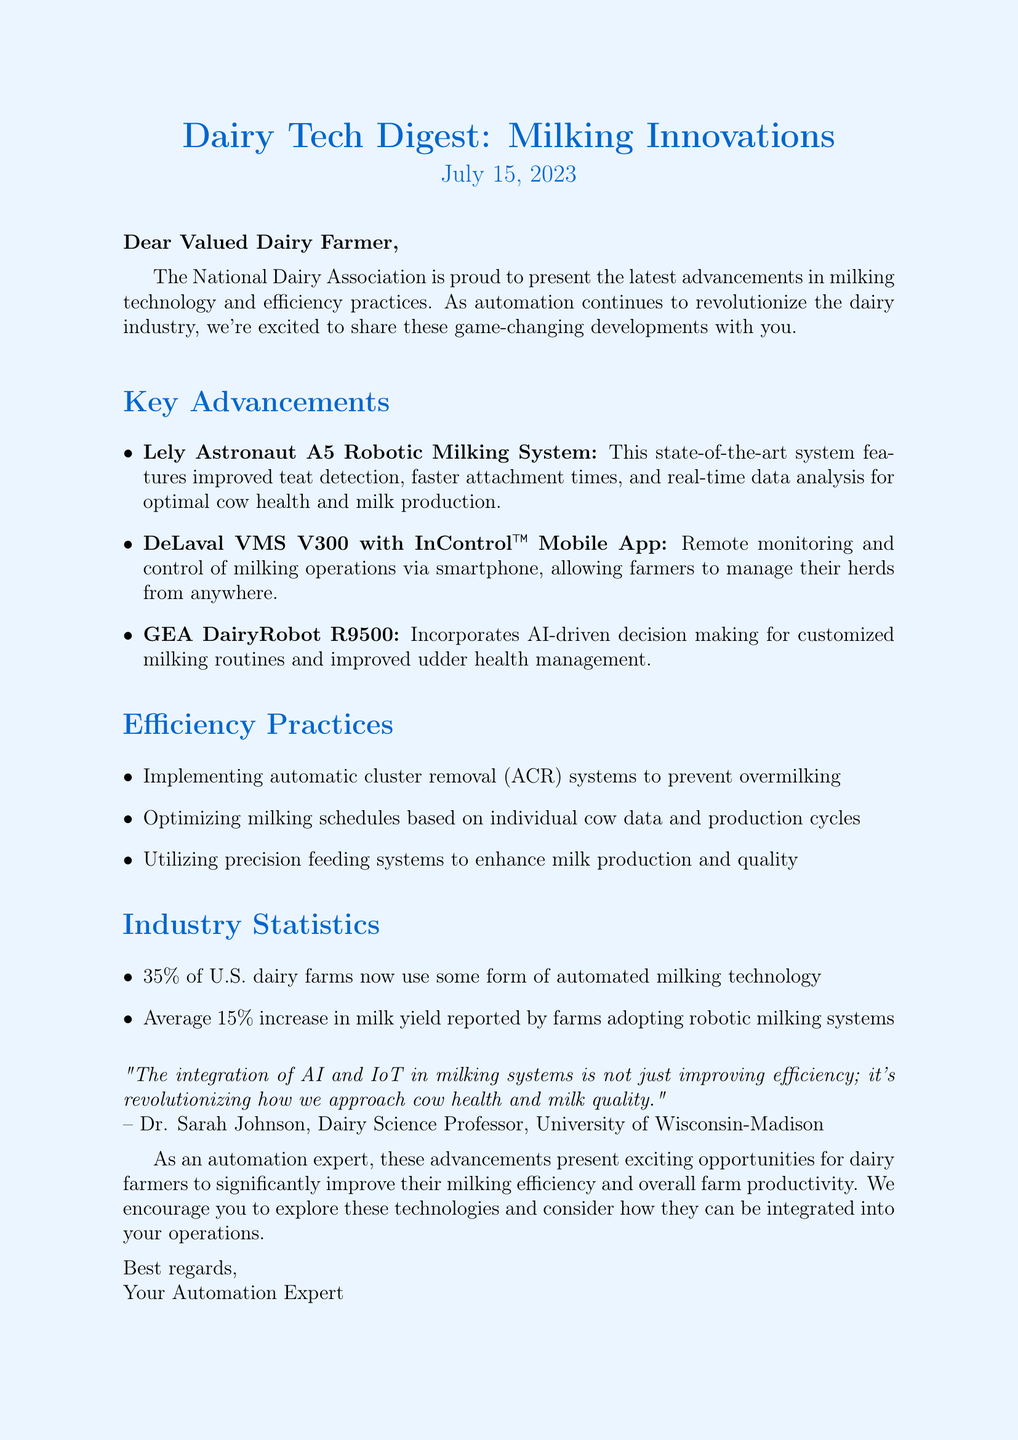what is the title of the newsletter? The title of the newsletter is presented at the top of the document.
Answer: Dairy Tech Digest: Milking Innovations when was the newsletter published? The publication date is specified in the header of the document.
Answer: July 15, 2023 who is the expert quoted in the newsletter? The expert's name is mentioned in the quote section of the document.
Answer: Dr. Sarah Johnson what percentage of U.S. dairy farms use automated milking technology? This statistic is provided under the industry statistics section.
Answer: 35% what is one of the key advancements mentioned in the newsletter? The document lists advancements under the key advancements section.
Answer: Lely Astronaut A5 Robotic Milking System what is the average increase in milk yield reported by farms using robotic milking systems? This information is found in the industry statistics section.
Answer: 15% what practice can help prevent overmilking? The document outlines efficiency practices, specifically mentioning this practice.
Answer: automatic cluster removal (ACR) systems how are farmers able to manage their herds remotely according to the newsletter? The newsletter explains this functionality under a specific advancement.
Answer: via smartphone what does the introduction state about automation in the dairy industry? The introduction gives insight into the role of automation as mentioned in the document.
Answer: revolutionize the dairy industry 